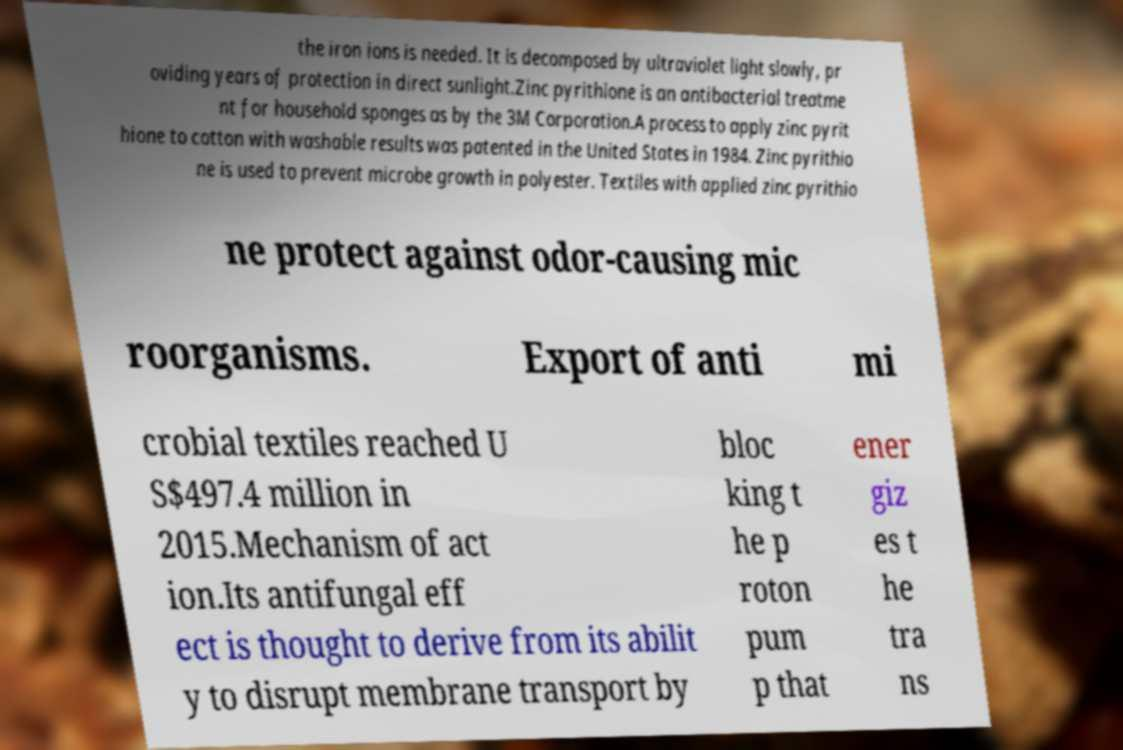What messages or text are displayed in this image? I need them in a readable, typed format. the iron ions is needed. It is decomposed by ultraviolet light slowly, pr oviding years of protection in direct sunlight.Zinc pyrithione is an antibacterial treatme nt for household sponges as by the 3M Corporation.A process to apply zinc pyrit hione to cotton with washable results was patented in the United States in 1984. Zinc pyrithio ne is used to prevent microbe growth in polyester. Textiles with applied zinc pyrithio ne protect against odor-causing mic roorganisms. Export of anti mi crobial textiles reached U S$497.4 million in 2015.Mechanism of act ion.Its antifungal eff ect is thought to derive from its abilit y to disrupt membrane transport by bloc king t he p roton pum p that ener giz es t he tra ns 